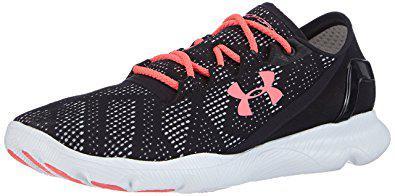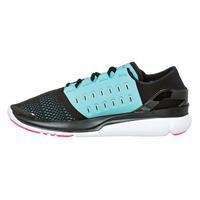The first image is the image on the left, the second image is the image on the right. For the images shown, is this caption "One of the images contains a pink and yellow shoe." true? Answer yes or no. No. The first image is the image on the left, the second image is the image on the right. Examine the images to the left and right. Is the description "There are three shoes." accurate? Answer yes or no. No. 